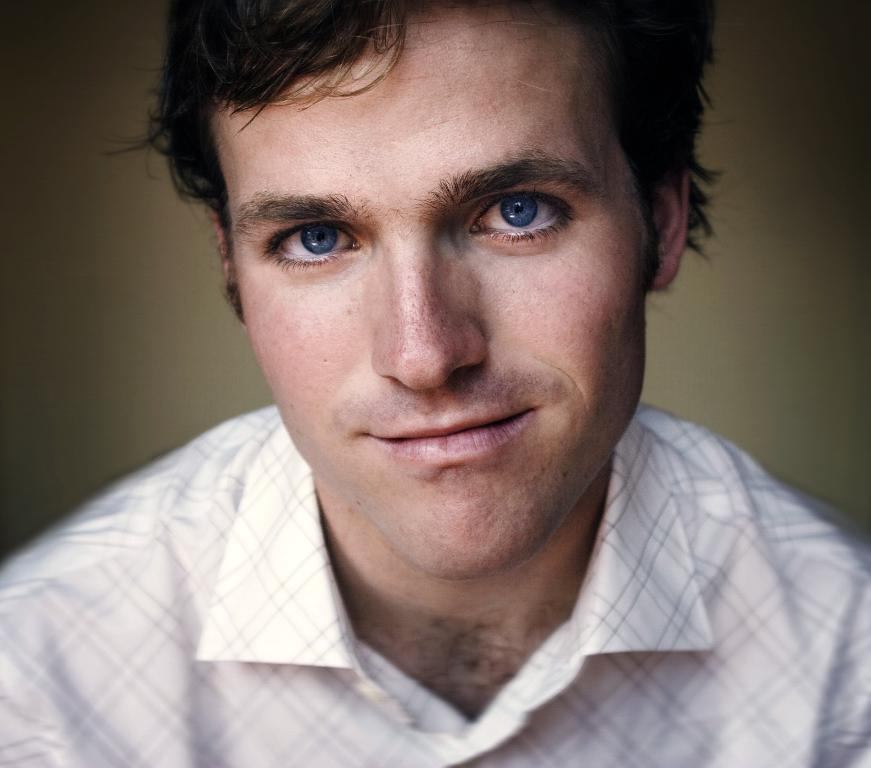Who is the main subject in the image? There is a man in the image. Where is the man positioned in the image? The man is in the front of the image. What is the man's facial expression in the image? The man is smiling in the image. What type of celery is the man holding in the image? There is no celery present in the image; the man is not holding any objects. How many things can be seen in the image? The question cannot be answered definitively based on the provided facts, as the term "things" is too vague. The image only shows a man in the front, smiling. 